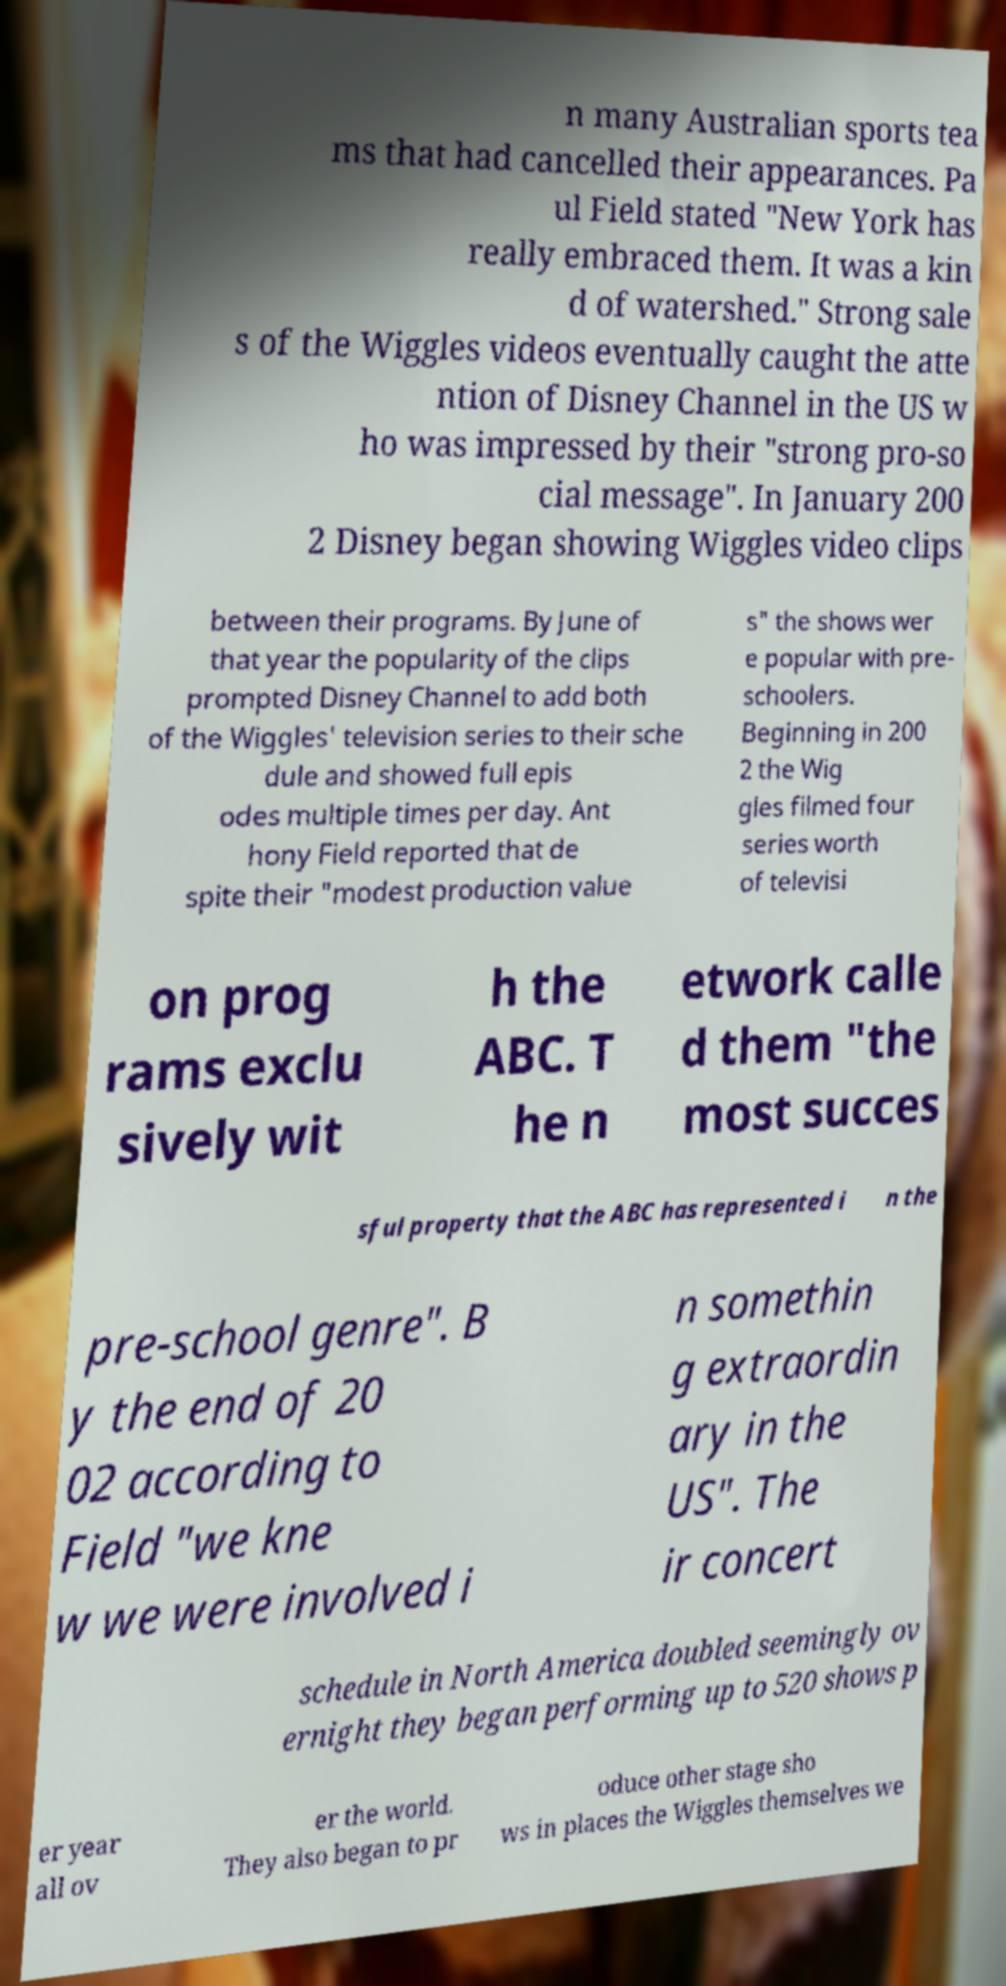Can you read and provide the text displayed in the image?This photo seems to have some interesting text. Can you extract and type it out for me? n many Australian sports tea ms that had cancelled their appearances. Pa ul Field stated "New York has really embraced them. It was a kin d of watershed." Strong sale s of the Wiggles videos eventually caught the atte ntion of Disney Channel in the US w ho was impressed by their "strong pro-so cial message". In January 200 2 Disney began showing Wiggles video clips between their programs. By June of that year the popularity of the clips prompted Disney Channel to add both of the Wiggles' television series to their sche dule and showed full epis odes multiple times per day. Ant hony Field reported that de spite their "modest production value s" the shows wer e popular with pre- schoolers. Beginning in 200 2 the Wig gles filmed four series worth of televisi on prog rams exclu sively wit h the ABC. T he n etwork calle d them "the most succes sful property that the ABC has represented i n the pre-school genre". B y the end of 20 02 according to Field "we kne w we were involved i n somethin g extraordin ary in the US". The ir concert schedule in North America doubled seemingly ov ernight they began performing up to 520 shows p er year all ov er the world. They also began to pr oduce other stage sho ws in places the Wiggles themselves we 